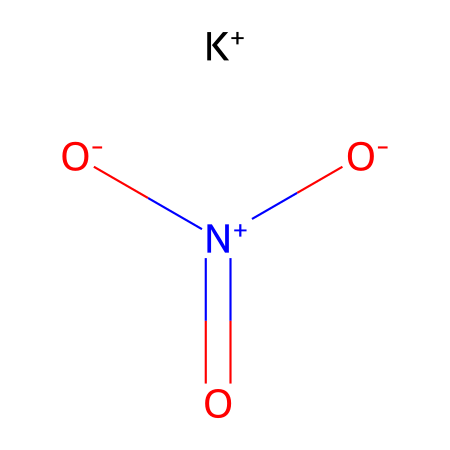What is the oxidation state of nitrogen in potassium nitrate? In the structure of potassium nitrate, nitrogen is connected to three oxygen atoms, where one oxygen carries a negative charge, while nitrogen itself has a positive formal charge. This results in the nitrogen having an oxidation state of +5.
Answer: +5 How many oxygen atoms are present in potassium nitrate? The structure shows that there are three oxygen atoms bonded to the nitrogen atom in potassium nitrate.
Answer: 3 What type of compound is potassium nitrate? Potassium nitrate is classified as a salt, as it is formed from the neutralization reaction between an acid (nitric acid) and a base (potassium hydroxide).
Answer: salt How many total atoms are in the potassium nitrate molecule? The molecule contains one potassium atom, one nitrogen atom, and three oxygen atoms. Adding these together gives a total of five atoms in the molecule.
Answer: 5 What is the primary role of potassium nitrate in special effects smoke? Potassium nitrate serves as an oxidizer, which provides the necessary oxygen to support the combustion of other materials when creating smoke.
Answer: oxidizer What kind of bonding is present in potassium nitrate? The structure of potassium nitrate includes ionic bonding between the potassium and nitrate ions, as well as covalent bonding within the nitrate ion itself.
Answer: ionic and covalent 